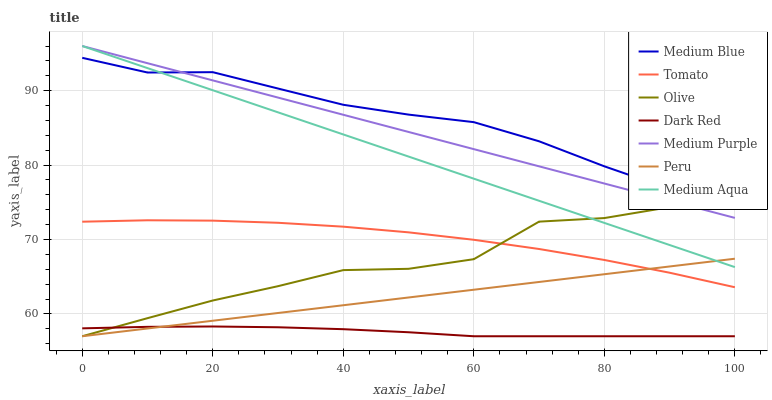Does Dark Red have the minimum area under the curve?
Answer yes or no. Yes. Does Medium Blue have the maximum area under the curve?
Answer yes or no. Yes. Does Medium Blue have the minimum area under the curve?
Answer yes or no. No. Does Dark Red have the maximum area under the curve?
Answer yes or no. No. Is Peru the smoothest?
Answer yes or no. Yes. Is Olive the roughest?
Answer yes or no. Yes. Is Dark Red the smoothest?
Answer yes or no. No. Is Dark Red the roughest?
Answer yes or no. No. Does Dark Red have the lowest value?
Answer yes or no. Yes. Does Medium Blue have the lowest value?
Answer yes or no. No. Does Medium Aqua have the highest value?
Answer yes or no. Yes. Does Medium Blue have the highest value?
Answer yes or no. No. Is Dark Red less than Medium Purple?
Answer yes or no. Yes. Is Medium Aqua greater than Tomato?
Answer yes or no. Yes. Does Olive intersect Peru?
Answer yes or no. Yes. Is Olive less than Peru?
Answer yes or no. No. Is Olive greater than Peru?
Answer yes or no. No. Does Dark Red intersect Medium Purple?
Answer yes or no. No. 